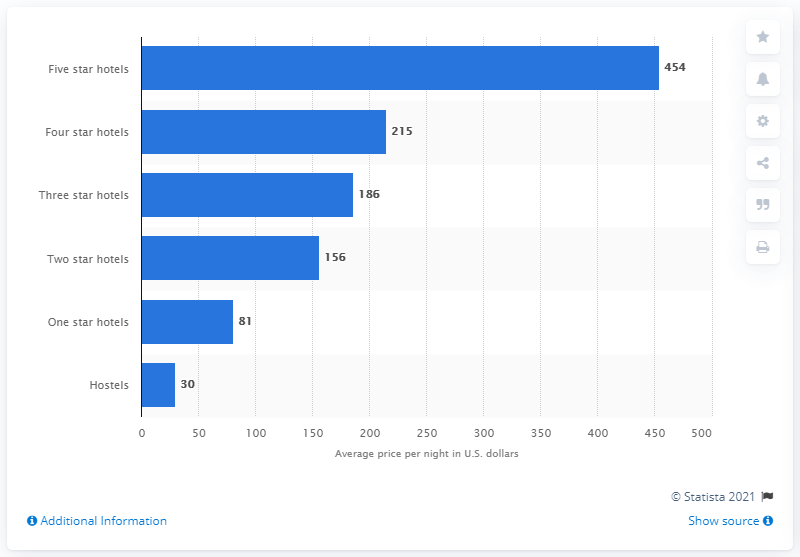Specify some key components in this picture. The average cost per night for a five-star hotel in San Francisco is 454 U.S. dollars. 